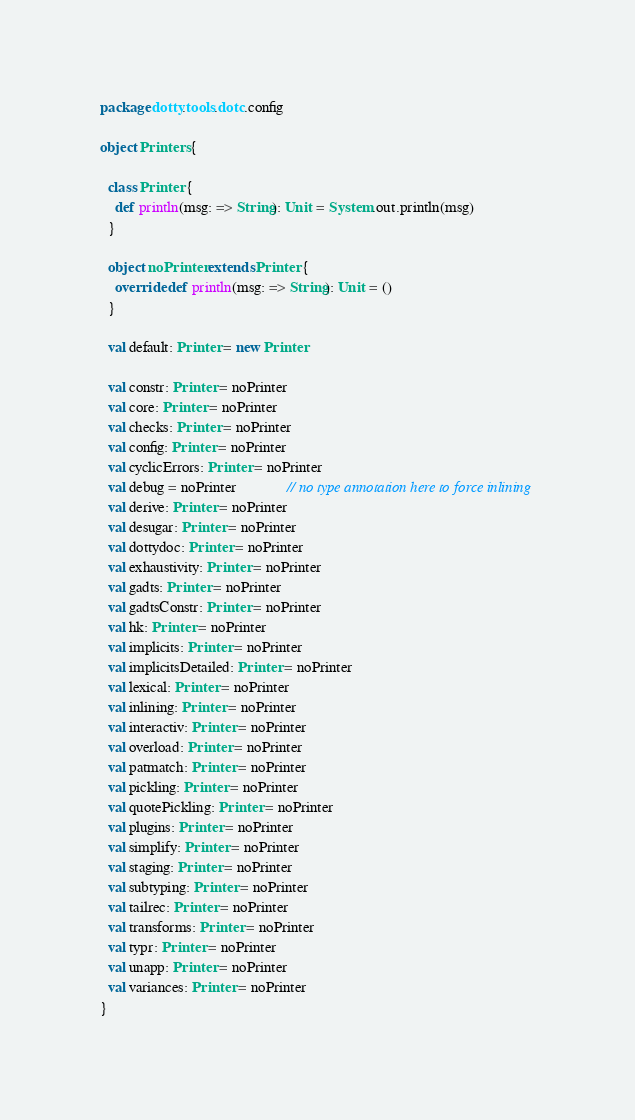Convert code to text. <code><loc_0><loc_0><loc_500><loc_500><_Scala_>package dotty.tools.dotc.config

object Printers {

  class Printer {
    def println(msg: => String): Unit = System.out.println(msg)
  }

  object noPrinter extends Printer {
    override def println(msg: => String): Unit = ()
  }

  val default: Printer = new Printer

  val constr: Printer = noPrinter
  val core: Printer = noPrinter
  val checks: Printer = noPrinter
  val config: Printer = noPrinter
  val cyclicErrors: Printer = noPrinter
  val debug = noPrinter             // no type annotation here to force inlining
  val derive: Printer = noPrinter
  val desugar: Printer = noPrinter
  val dottydoc: Printer = noPrinter
  val exhaustivity: Printer = noPrinter
  val gadts: Printer = noPrinter
  val gadtsConstr: Printer = noPrinter
  val hk: Printer = noPrinter
  val implicits: Printer = noPrinter
  val implicitsDetailed: Printer = noPrinter
  val lexical: Printer = noPrinter
  val inlining: Printer = noPrinter
  val interactiv: Printer = noPrinter
  val overload: Printer = noPrinter
  val patmatch: Printer = noPrinter
  val pickling: Printer = noPrinter
  val quotePickling: Printer = noPrinter
  val plugins: Printer = noPrinter
  val simplify: Printer = noPrinter
  val staging: Printer = noPrinter
  val subtyping: Printer = noPrinter
  val tailrec: Printer = noPrinter
  val transforms: Printer = noPrinter
  val typr: Printer = noPrinter
  val unapp: Printer = noPrinter
  val variances: Printer = noPrinter
}
</code> 